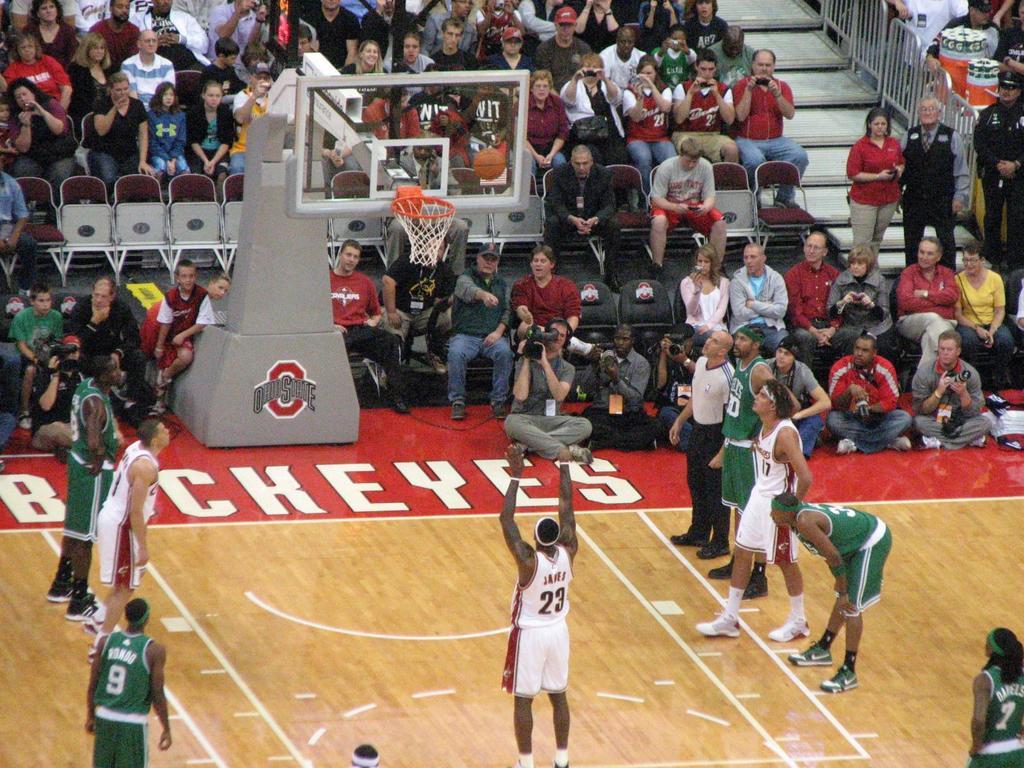What school's stadium is this?
Your answer should be compact. Ohio state. What number is the player in the green jersey on the bottom left wearing?
Keep it short and to the point. 9. 